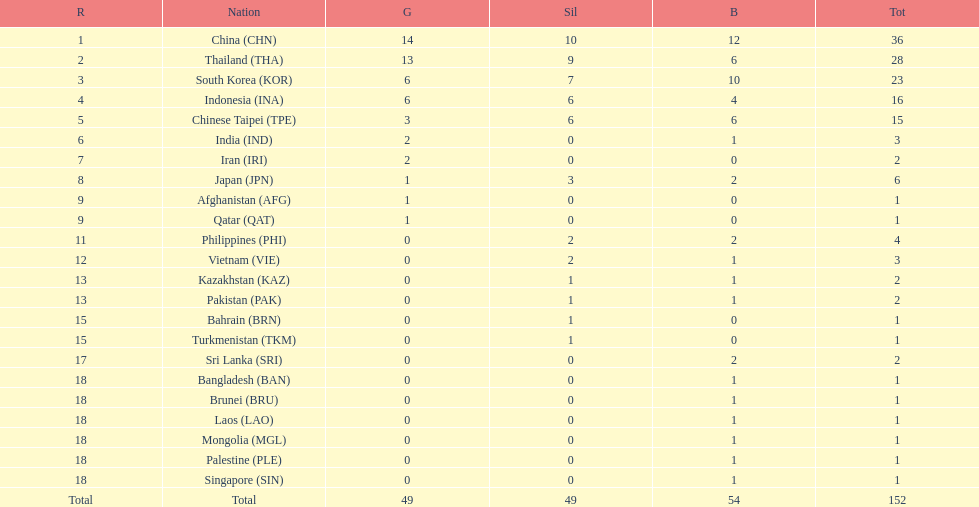How many additional medals did india obtain in comparison to pakistan? 1. 